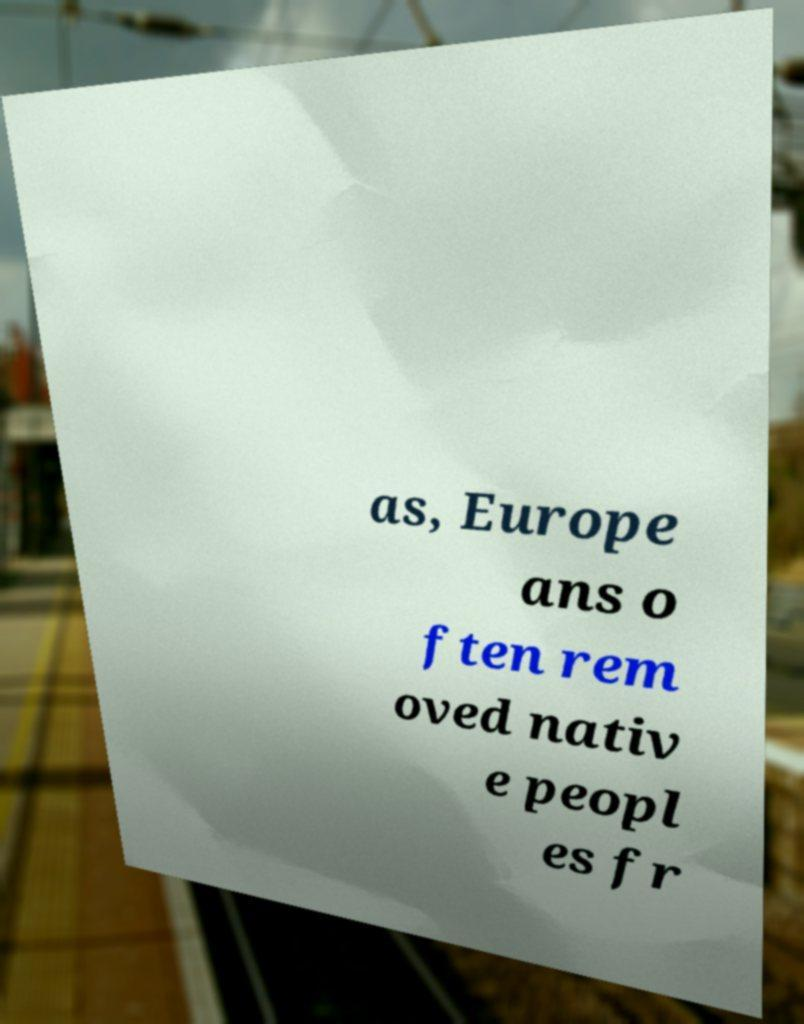There's text embedded in this image that I need extracted. Can you transcribe it verbatim? as, Europe ans o ften rem oved nativ e peopl es fr 